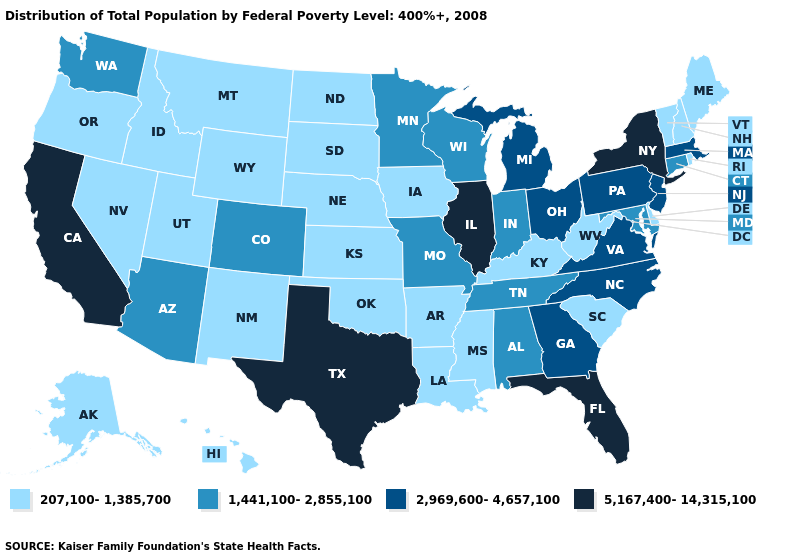What is the value of Alaska?
Answer briefly. 207,100-1,385,700. Among the states that border Nebraska , does Colorado have the highest value?
Keep it brief. Yes. What is the value of Colorado?
Answer briefly. 1,441,100-2,855,100. What is the value of Ohio?
Write a very short answer. 2,969,600-4,657,100. Which states have the lowest value in the USA?
Give a very brief answer. Alaska, Arkansas, Delaware, Hawaii, Idaho, Iowa, Kansas, Kentucky, Louisiana, Maine, Mississippi, Montana, Nebraska, Nevada, New Hampshire, New Mexico, North Dakota, Oklahoma, Oregon, Rhode Island, South Carolina, South Dakota, Utah, Vermont, West Virginia, Wyoming. What is the value of Missouri?
Keep it brief. 1,441,100-2,855,100. Name the states that have a value in the range 2,969,600-4,657,100?
Quick response, please. Georgia, Massachusetts, Michigan, New Jersey, North Carolina, Ohio, Pennsylvania, Virginia. What is the highest value in the MidWest ?
Keep it brief. 5,167,400-14,315,100. Among the states that border Kansas , does Oklahoma have the lowest value?
Answer briefly. Yes. How many symbols are there in the legend?
Be succinct. 4. What is the value of Colorado?
Be succinct. 1,441,100-2,855,100. Among the states that border Mississippi , does Arkansas have the highest value?
Answer briefly. No. Is the legend a continuous bar?
Give a very brief answer. No. What is the value of Colorado?
Keep it brief. 1,441,100-2,855,100. Does Kansas have the lowest value in the MidWest?
Quick response, please. Yes. 